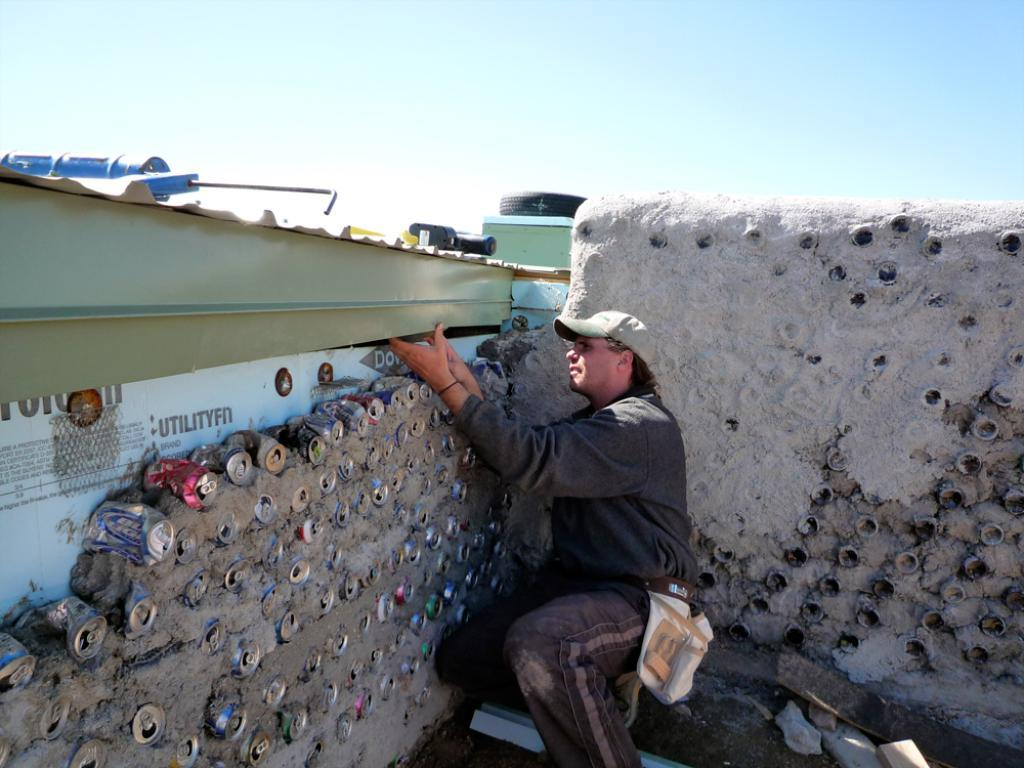Provide a one-sentence caption for the provided image. A man is working near a wall that has the word UTILITYFN on it. 